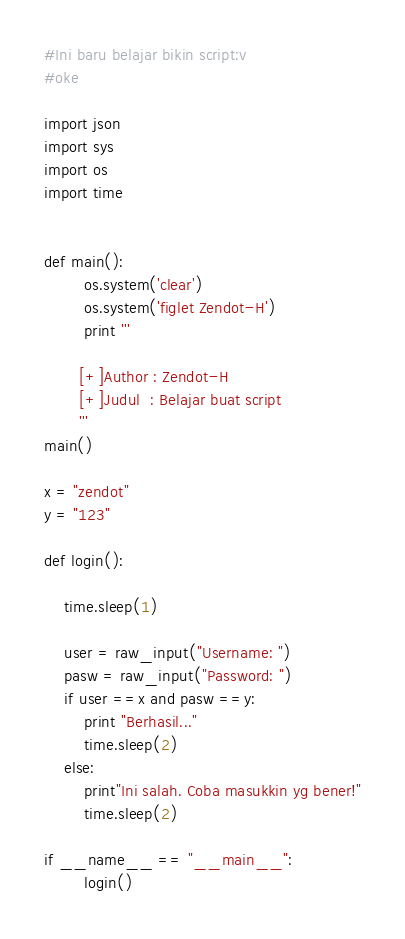<code> <loc_0><loc_0><loc_500><loc_500><_Python_>#Ini baru belajar bikin script:v
#oke

import json
import sys
import os
import time


def main():
        os.system('clear')
        os.system('figlet Zendot-H')
        print '''

       [+]Author : Zendot-H
       [+]Judul  : Belajar buat script
       '''
main()

x = "zendot"
y = "123"

def login():

    time.sleep(1)

    user = raw_input("Username: ")
    pasw = raw_input("Password: ")
    if user ==x and pasw ==y:
        print "Berhasil..."
        time.sleep(2)
    else:
        print"Ini salah. Coba masukkin yg bener!"
        time.sleep(2)

if __name__ == "__main__":
        login()</code> 